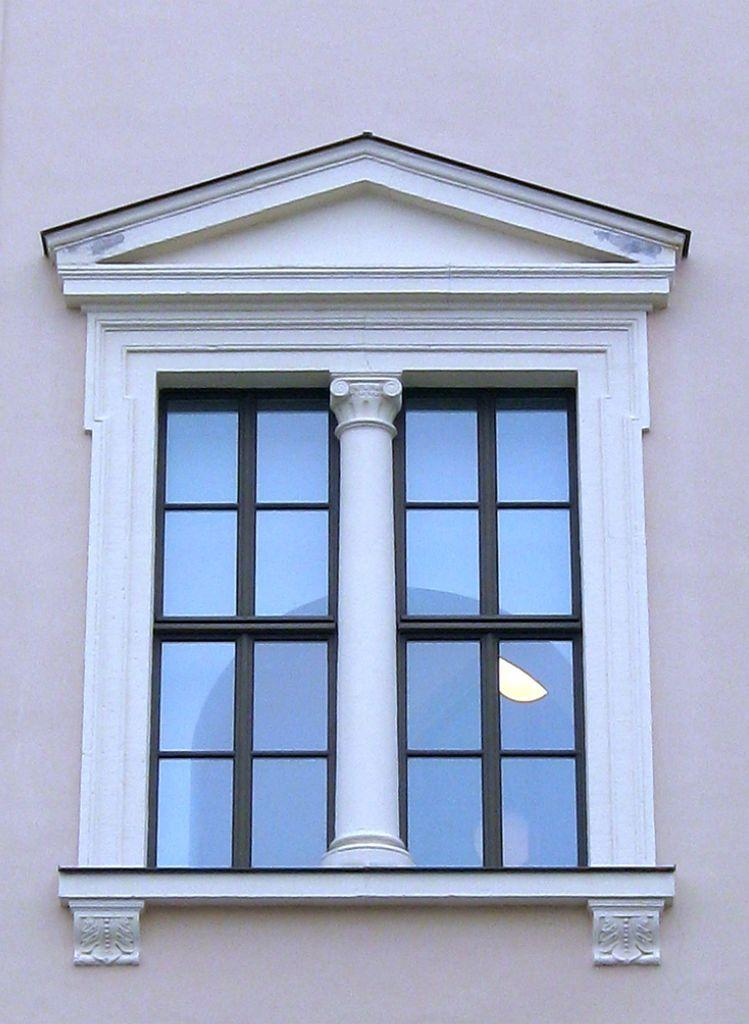What type of opening can be seen in the image? There is a window in the image. What type of structure is present in the image? There is a wall in the image. What type of horn can be seen on the cattle in the image? There are no cattle or horns present in the image; it only features a window and a wall. 